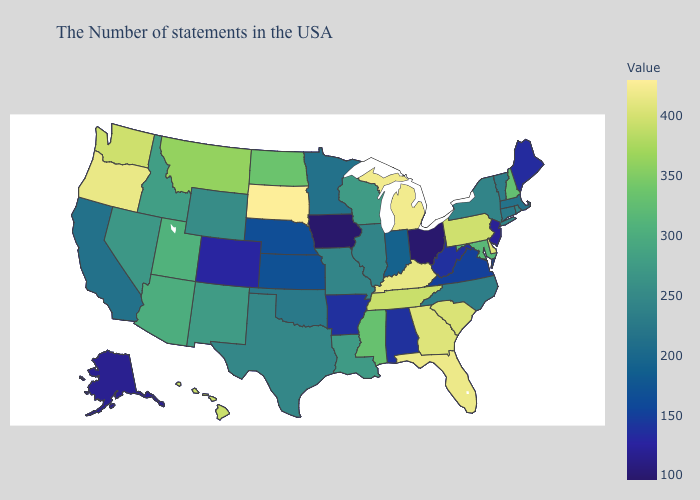Which states have the lowest value in the West?
Short answer required. Alaska. Does West Virginia have the lowest value in the South?
Quick response, please. Yes. Does California have a higher value than Florida?
Be succinct. No. Which states have the lowest value in the South?
Write a very short answer. West Virginia, Arkansas. Among the states that border Kentucky , which have the lowest value?
Be succinct. Ohio. 